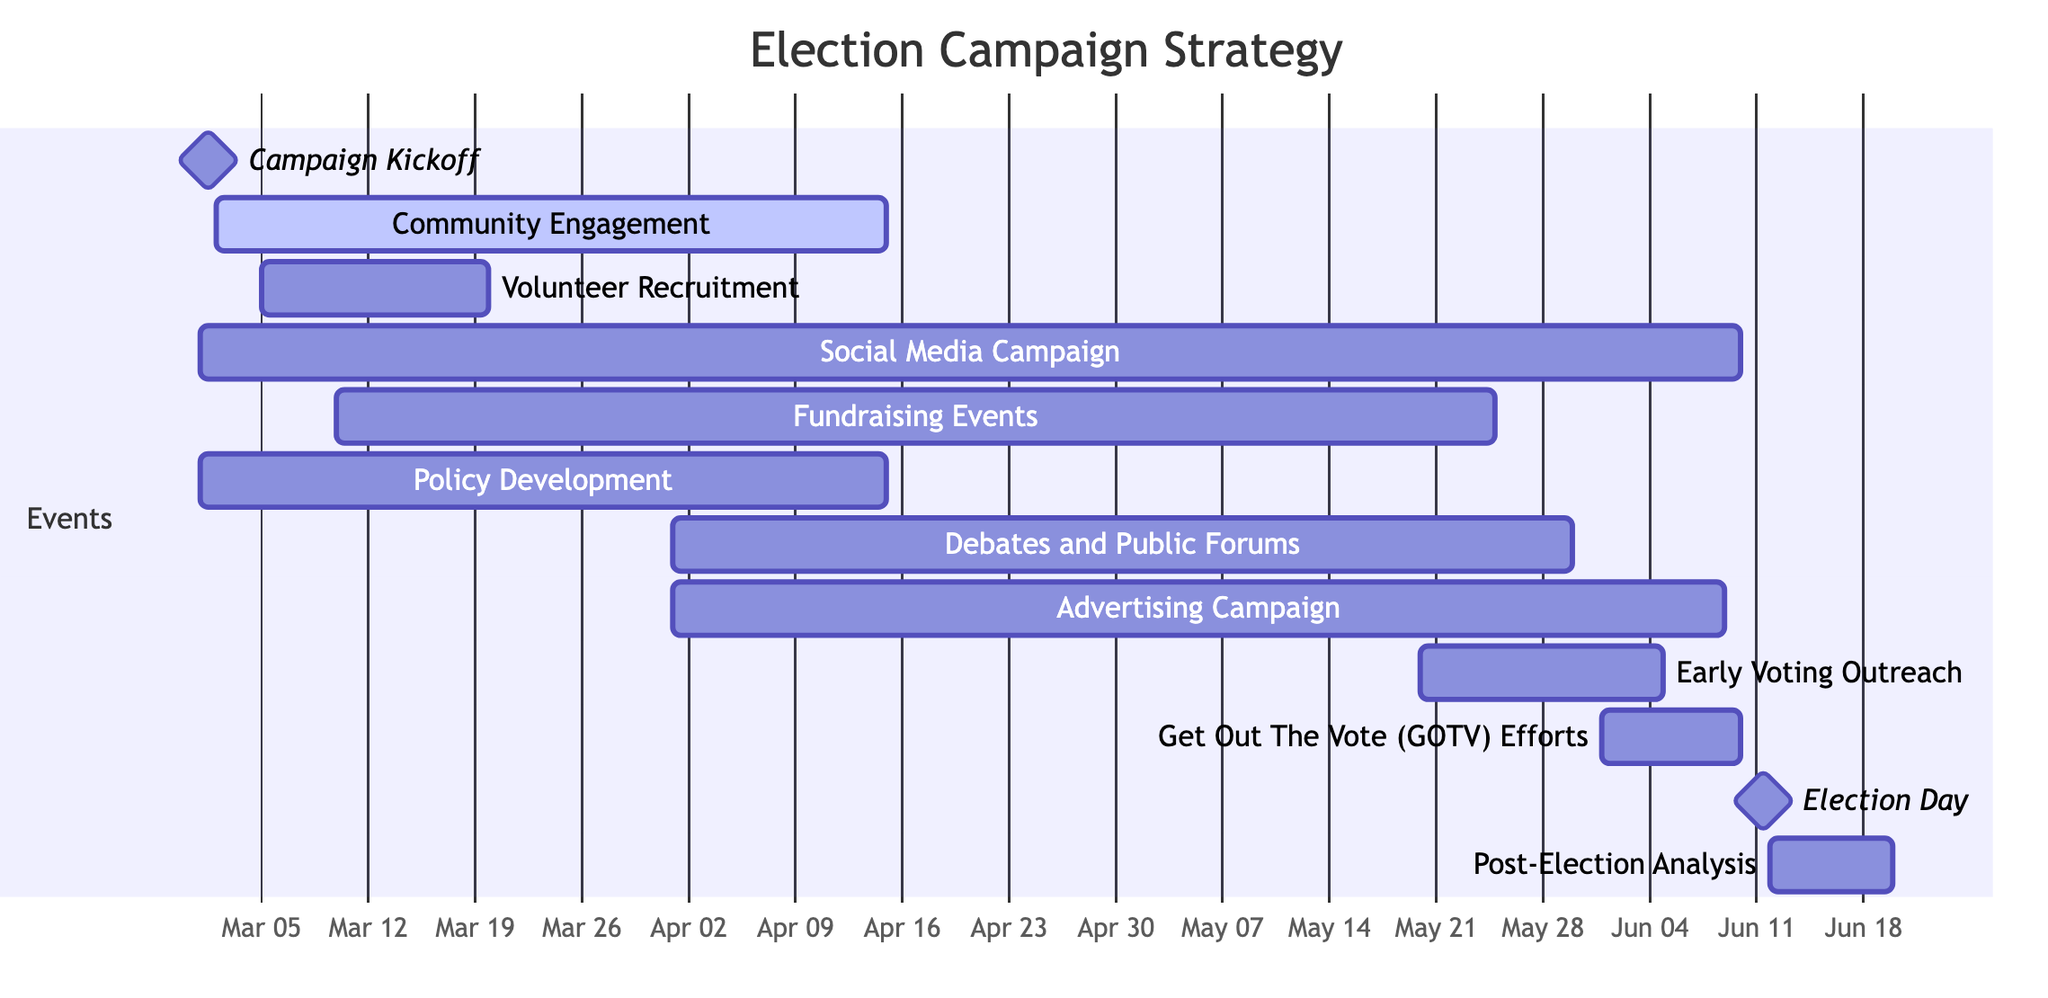What's the duration of the "Community Engagement" event? The "Community Engagement" event starts on March 2, 2023, and ends on April 15, 2023. To find the duration, we count the days from the start date to the end date, which is a total of 44 days.
Answer: 44 days What are the dates for the "Election Day" milestone? The "Election Day" milestone is specified with a start date and an end date of June 11, 2023. Since it lasts for only one day, both dates are the same.
Answer: June 11, 2023 Which event overlaps with the "Get Out The Vote (GOTV) Efforts"? The "Get Out The Vote (GOTV) Efforts" run from June 1, 2023, to June 10, 2023. During this time, the "Election Day" milestone occurs on June 11, 2023, but no other event overlaps in terms of having the same days.
Answer: None How many events are scheduled before April 1, 2023? The events scheduled before April 1, 2023, are "Campaign Kickoff" on March 1, "Social Media Campaign" from March 1 to June 10, "Volunteer Recruitment" from March 5 to March 20, "Fundraising Events" from March 10 to May 25, and "Policy Development" from March 1 to April 15. Counting these, we find there are four distinct events.
Answer: 4 events What is the main purpose of the "Fundraising Events"? The "Fundraising Events" are organized to gather financial support for the campaign, and this can be inferred from its description which indicates it includes activities like dinners, auctions, and charity runs. This suggests that the primary focus is on generating funds.
Answer: Gather financial support Which two events start on the same date? The events "Campaign Kickoff" and "Social Media Campaign" both start on March 1, 2023. This can be determined by looking at the start dates of the listed events in the diagram.
Answer: Campaign Kickoff and Social Media Campaign What is the last event before the "Post-Election Analysis"? The last event before the "Post-Election Analysis" is "Election Day," which takes place on June 11, 2023. This is clear from the timeline of events leading to the analysis, as the analysis starts the day after Election Day.
Answer: Election Day How long does the "Advertising Campaign" last? The "Advertising Campaign" starts on April 1, 2023, and ends on June 9, 2023. Calculating the duration involves counting days from the start date to the end date, which gives us 70 days.
Answer: 70 days Which event has the shortest duration? The "Campaign Kickoff" is a milestone that lasts for just one day on March 1, 2023. Other events extend over multiple days or weeks, making it the shortest duration event in the campaign timeline.
Answer: Campaign Kickoff 